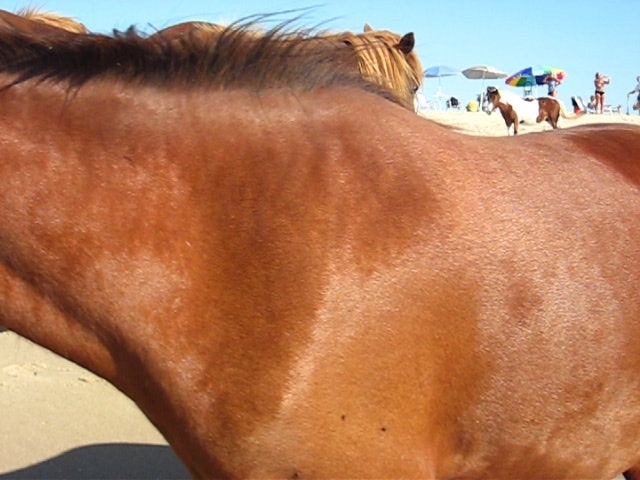Describe the objects in this image and their specific colors. I can see horse in brown, lightblue, tan, and salmon tones, horse in lightblue, ivory, brown, maroon, and darkgray tones, umbrella in lightblue, ivory, teal, and navy tones, umbrella in lightblue, darkgray, white, and gray tones, and people in lightblue, lightgray, gray, lightpink, and darkgray tones in this image. 